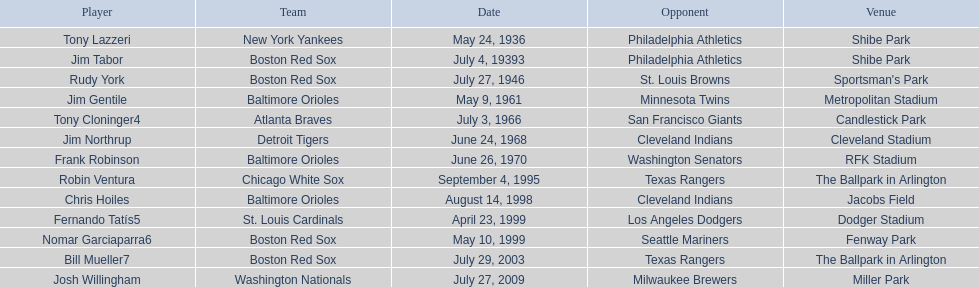Who were all the groups? New York Yankees, Boston Red Sox, Boston Red Sox, Baltimore Orioles, Atlanta Braves, Detroit Tigers, Baltimore Orioles, Chicago White Sox, Baltimore Orioles, St. Louis Cardinals, Boston Red Sox, Boston Red Sox, Washington Nationals. What about adversaries? Philadelphia Athletics, Philadelphia Athletics, St. Louis Browns, Minnesota Twins, San Francisco Giants, Cleveland Indians, Washington Senators, Texas Rangers, Cleveland Indians, Los Angeles Dodgers, Seattle Mariners, Texas Rangers, Milwaukee Brewers. And when did they compete? May 24, 1936, July 4, 19393, July 27, 1946, May 9, 1961, July 3, 1966, June 24, 1968, June 26, 1970, September 4, 1995, August 14, 1998, April 23, 1999, May 10, 1999, July 29, 2003, July 27, 2009. Which group faced the red sox on july 27, 1946? St. Louis Browns. Could you help me parse every detail presented in this table? {'header': ['Player', 'Team', 'Date', 'Opponent', 'Venue'], 'rows': [['Tony Lazzeri', 'New York Yankees', 'May 24, 1936', 'Philadelphia Athletics', 'Shibe Park'], ['Jim Tabor', 'Boston Red Sox', 'July 4, 19393', 'Philadelphia Athletics', 'Shibe Park'], ['Rudy York', 'Boston Red Sox', 'July 27, 1946', 'St. Louis Browns', "Sportsman's Park"], ['Jim Gentile', 'Baltimore Orioles', 'May 9, 1961', 'Minnesota Twins', 'Metropolitan Stadium'], ['Tony Cloninger4', 'Atlanta Braves', 'July 3, 1966', 'San Francisco Giants', 'Candlestick Park'], ['Jim Northrup', 'Detroit Tigers', 'June 24, 1968', 'Cleveland Indians', 'Cleveland Stadium'], ['Frank Robinson', 'Baltimore Orioles', 'June 26, 1970', 'Washington Senators', 'RFK Stadium'], ['Robin Ventura', 'Chicago White Sox', 'September 4, 1995', 'Texas Rangers', 'The Ballpark in Arlington'], ['Chris Hoiles', 'Baltimore Orioles', 'August 14, 1998', 'Cleveland Indians', 'Jacobs Field'], ['Fernando Tatís5', 'St. Louis Cardinals', 'April 23, 1999', 'Los Angeles Dodgers', 'Dodger Stadium'], ['Nomar Garciaparra6', 'Boston Red Sox', 'May 10, 1999', 'Seattle Mariners', 'Fenway Park'], ['Bill Mueller7', 'Boston Red Sox', 'July 29, 2003', 'Texas Rangers', 'The Ballpark in Arlington'], ['Josh Willingham', 'Washington Nationals', 'July 27, 2009', 'Milwaukee Brewers', 'Miller Park']]} 